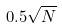<formula> <loc_0><loc_0><loc_500><loc_500>0 . 5 \sqrt { N }</formula> 